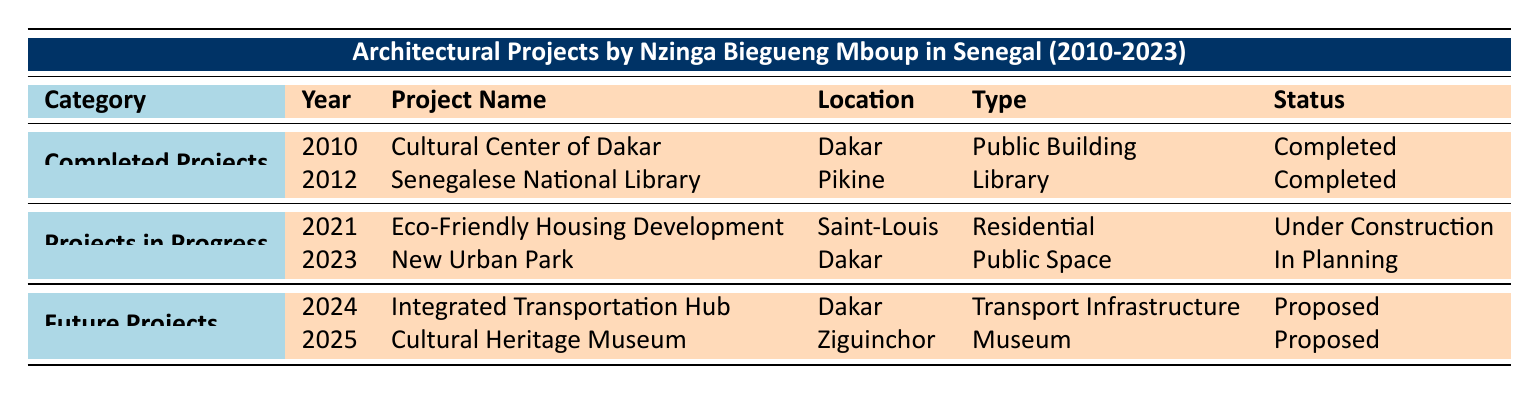What is the name of the project completed in 2010? The table indicates that the project completed in 2010 is the "Cultural Center of Dakar."
Answer: Cultural Center of Dakar How many projects are categorized as "Completed Projects"? There are two projects listed under "Completed Projects": "Cultural Center of Dakar" and "Senegalese National Library."
Answer: 2 Which project is currently "Under Construction"? According to the table, the project that is "Under Construction" is the "Eco-Friendly Housing Development" in Saint-Louis.
Answer: Eco-Friendly Housing Development Is the "New Urban Park" completed? The table states that the "New Urban Park" is currently "In Planning," meaning it is not completed.
Answer: No What are the types of projects proposed for future development in Dakar? The table lists two future projects in Dakar: "Integrated Transportation Hub" (Transport Infrastructure) and "Cultural Heritage Museum" (Museum).
Answer: Transport Infrastructure, Museum What is the total number of projects listed for 2023? There are two projects; one is "New Urban Park" which is "In Planning" and one "Cultural Heritage Museum" which is "Proposed." We sum them for the total count, which gives us 2.
Answer: 2 In which year was the Senegalese National Library completed? The table shows that the Senegalese National Library was completed in the year 2012.
Answer: 2012 Which project focusing on sustainability is currently in progress? The table identifies that the "Eco-Friendly Housing Development" focuses on sustainability and is "Under Construction."
Answer: Eco-Friendly Housing Development How many total projects does Nzinga Biegueng Mboup have planned for the future? There are two future projects listed in the table: "Integrated Transportation Hub" for 2024 and "Cultural Heritage Museum" for 2025, so we conclude that there are 2 planned future projects.
Answer: 2 